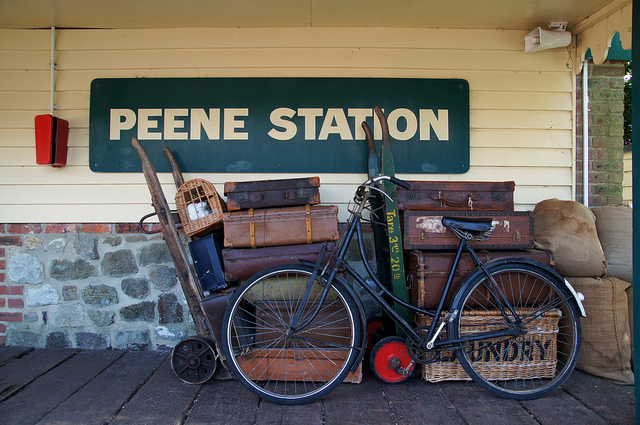Please transcribe the text information in this image. PEENE STATION 